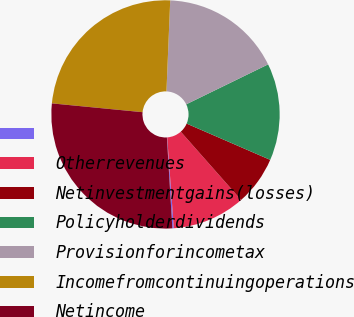<chart> <loc_0><loc_0><loc_500><loc_500><pie_chart><ecel><fcel>Otherrevenues<fcel>Netinvestmentgains(losses)<fcel>Policyholderdividends<fcel>Provisionforincometax<fcel>Incomefromcontinuingoperations<fcel>Netincome<nl><fcel>0.21%<fcel>10.35%<fcel>6.97%<fcel>13.74%<fcel>17.12%<fcel>24.12%<fcel>27.5%<nl></chart> 